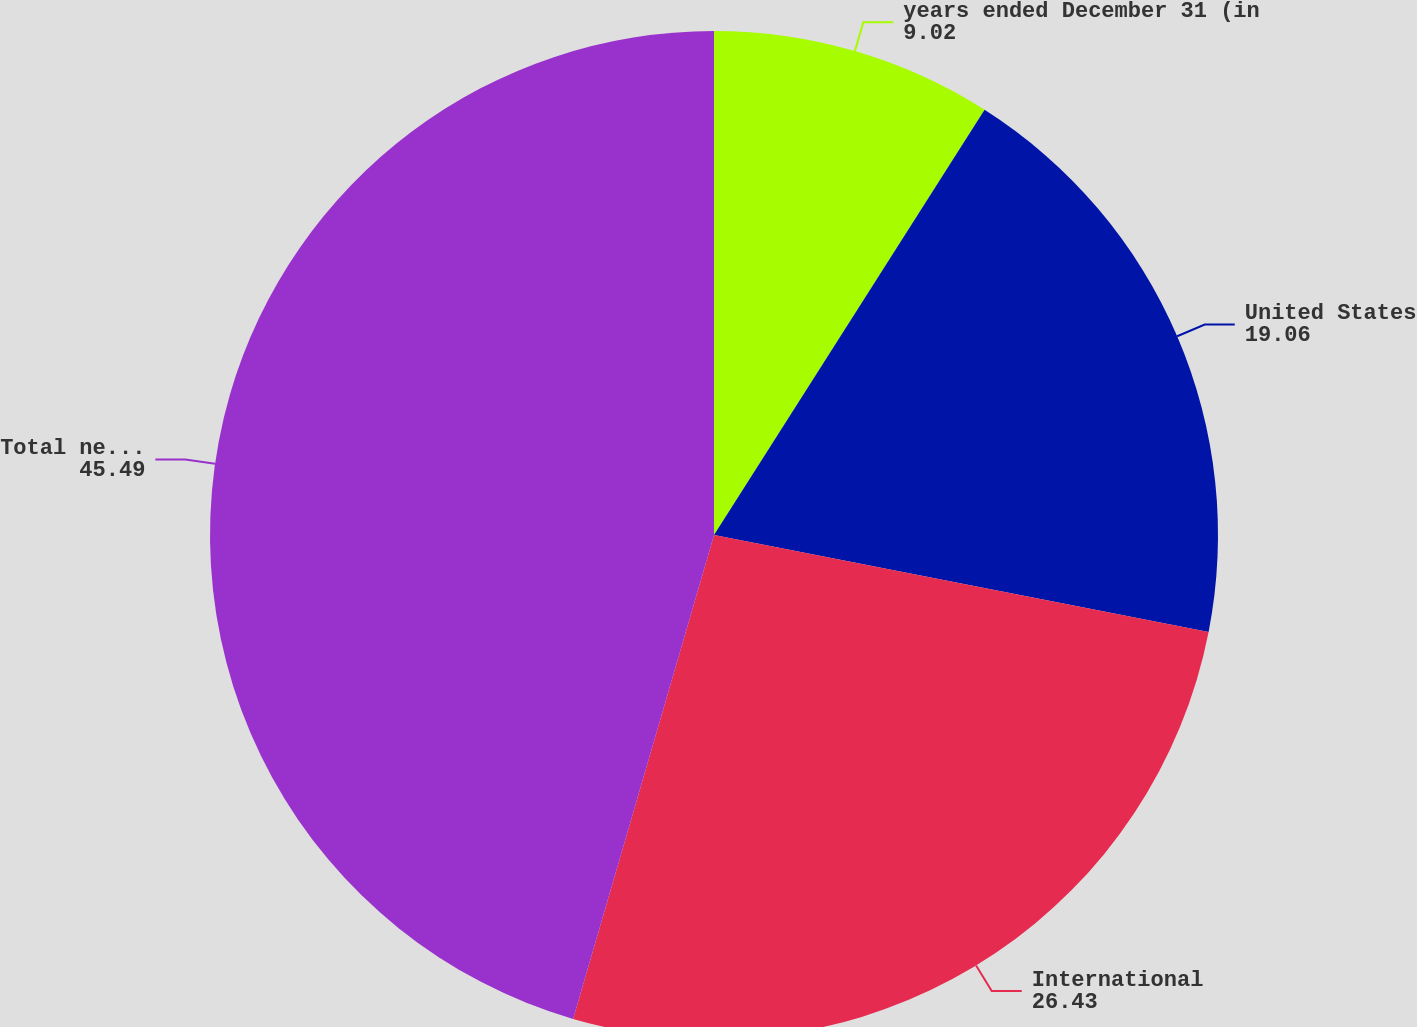Convert chart to OTSL. <chart><loc_0><loc_0><loc_500><loc_500><pie_chart><fcel>years ended December 31 (in<fcel>United States<fcel>International<fcel>Total net sales<nl><fcel>9.02%<fcel>19.06%<fcel>26.43%<fcel>45.49%<nl></chart> 